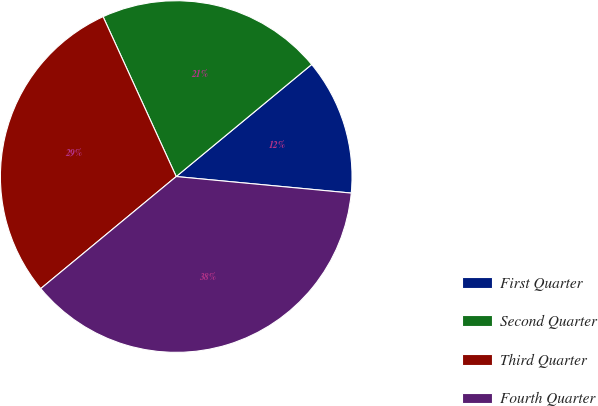Convert chart. <chart><loc_0><loc_0><loc_500><loc_500><pie_chart><fcel>First Quarter<fcel>Second Quarter<fcel>Third Quarter<fcel>Fourth Quarter<nl><fcel>12.5%<fcel>20.83%<fcel>29.17%<fcel>37.5%<nl></chart> 